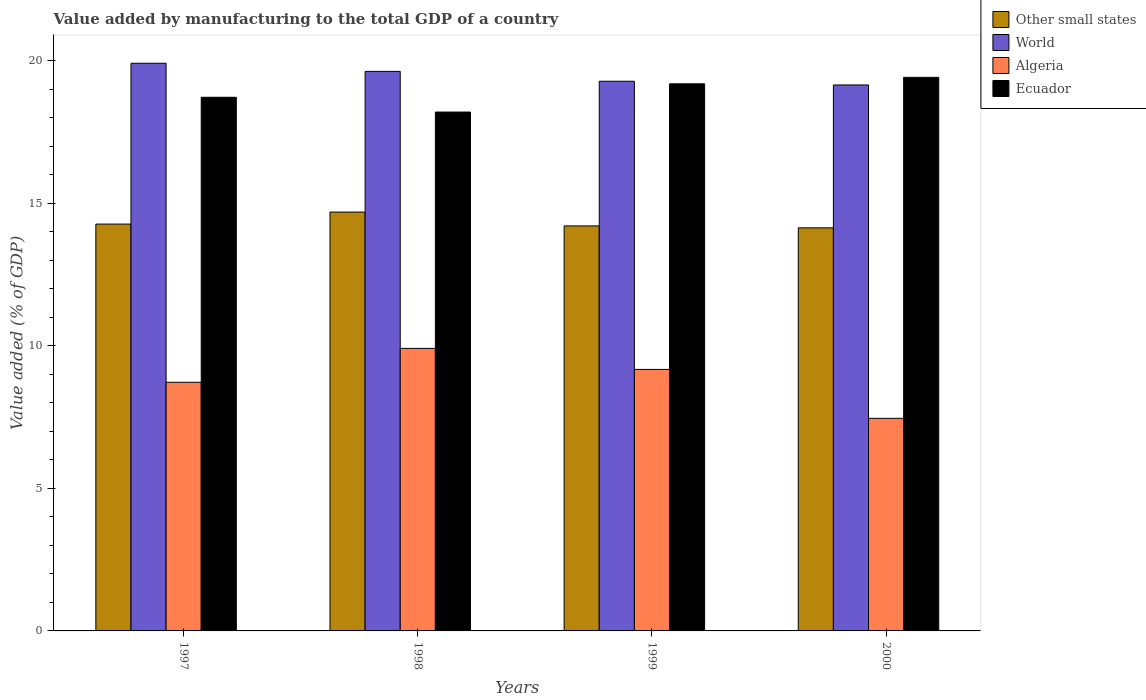How many different coloured bars are there?
Your response must be concise. 4. Are the number of bars per tick equal to the number of legend labels?
Give a very brief answer. Yes. What is the label of the 2nd group of bars from the left?
Your response must be concise. 1998. In how many cases, is the number of bars for a given year not equal to the number of legend labels?
Make the answer very short. 0. What is the value added by manufacturing to the total GDP in World in 2000?
Offer a very short reply. 19.15. Across all years, what is the maximum value added by manufacturing to the total GDP in Algeria?
Offer a terse response. 9.91. Across all years, what is the minimum value added by manufacturing to the total GDP in Other small states?
Give a very brief answer. 14.14. In which year was the value added by manufacturing to the total GDP in Algeria maximum?
Keep it short and to the point. 1998. In which year was the value added by manufacturing to the total GDP in World minimum?
Keep it short and to the point. 2000. What is the total value added by manufacturing to the total GDP in Other small states in the graph?
Offer a terse response. 57.3. What is the difference between the value added by manufacturing to the total GDP in Ecuador in 1999 and that in 2000?
Provide a succinct answer. -0.23. What is the difference between the value added by manufacturing to the total GDP in Algeria in 1997 and the value added by manufacturing to the total GDP in Other small states in 1998?
Your response must be concise. -5.97. What is the average value added by manufacturing to the total GDP in World per year?
Give a very brief answer. 19.49. In the year 1999, what is the difference between the value added by manufacturing to the total GDP in Algeria and value added by manufacturing to the total GDP in Other small states?
Your answer should be compact. -5.03. In how many years, is the value added by manufacturing to the total GDP in Other small states greater than 7 %?
Provide a succinct answer. 4. What is the ratio of the value added by manufacturing to the total GDP in World in 1999 to that in 2000?
Your response must be concise. 1.01. Is the value added by manufacturing to the total GDP in Ecuador in 1999 less than that in 2000?
Provide a succinct answer. Yes. What is the difference between the highest and the second highest value added by manufacturing to the total GDP in Other small states?
Your response must be concise. 0.42. What is the difference between the highest and the lowest value added by manufacturing to the total GDP in Algeria?
Ensure brevity in your answer.  2.45. In how many years, is the value added by manufacturing to the total GDP in Algeria greater than the average value added by manufacturing to the total GDP in Algeria taken over all years?
Your answer should be very brief. 2. Is the sum of the value added by manufacturing to the total GDP in Ecuador in 1998 and 1999 greater than the maximum value added by manufacturing to the total GDP in Other small states across all years?
Give a very brief answer. Yes. Is it the case that in every year, the sum of the value added by manufacturing to the total GDP in Ecuador and value added by manufacturing to the total GDP in World is greater than the sum of value added by manufacturing to the total GDP in Other small states and value added by manufacturing to the total GDP in Algeria?
Provide a short and direct response. Yes. What does the 4th bar from the left in 2000 represents?
Your response must be concise. Ecuador. What does the 1st bar from the right in 2000 represents?
Provide a short and direct response. Ecuador. Is it the case that in every year, the sum of the value added by manufacturing to the total GDP in Other small states and value added by manufacturing to the total GDP in Ecuador is greater than the value added by manufacturing to the total GDP in Algeria?
Offer a very short reply. Yes. How many years are there in the graph?
Ensure brevity in your answer.  4. Are the values on the major ticks of Y-axis written in scientific E-notation?
Offer a terse response. No. Does the graph contain any zero values?
Your answer should be compact. No. Where does the legend appear in the graph?
Provide a short and direct response. Top right. How many legend labels are there?
Provide a short and direct response. 4. How are the legend labels stacked?
Make the answer very short. Vertical. What is the title of the graph?
Offer a terse response. Value added by manufacturing to the total GDP of a country. Does "Congo (Republic)" appear as one of the legend labels in the graph?
Give a very brief answer. No. What is the label or title of the Y-axis?
Offer a very short reply. Value added (% of GDP). What is the Value added (% of GDP) of Other small states in 1997?
Provide a short and direct response. 14.27. What is the Value added (% of GDP) in World in 1997?
Give a very brief answer. 19.91. What is the Value added (% of GDP) in Algeria in 1997?
Make the answer very short. 8.72. What is the Value added (% of GDP) of Ecuador in 1997?
Keep it short and to the point. 18.72. What is the Value added (% of GDP) in Other small states in 1998?
Ensure brevity in your answer.  14.69. What is the Value added (% of GDP) in World in 1998?
Offer a terse response. 19.63. What is the Value added (% of GDP) in Algeria in 1998?
Make the answer very short. 9.91. What is the Value added (% of GDP) of Ecuador in 1998?
Provide a succinct answer. 18.2. What is the Value added (% of GDP) in Other small states in 1999?
Provide a succinct answer. 14.21. What is the Value added (% of GDP) in World in 1999?
Provide a short and direct response. 19.28. What is the Value added (% of GDP) in Algeria in 1999?
Your response must be concise. 9.17. What is the Value added (% of GDP) in Ecuador in 1999?
Give a very brief answer. 19.19. What is the Value added (% of GDP) of Other small states in 2000?
Provide a succinct answer. 14.14. What is the Value added (% of GDP) in World in 2000?
Ensure brevity in your answer.  19.15. What is the Value added (% of GDP) of Algeria in 2000?
Provide a succinct answer. 7.46. What is the Value added (% of GDP) of Ecuador in 2000?
Offer a terse response. 19.42. Across all years, what is the maximum Value added (% of GDP) in Other small states?
Offer a terse response. 14.69. Across all years, what is the maximum Value added (% of GDP) in World?
Provide a short and direct response. 19.91. Across all years, what is the maximum Value added (% of GDP) in Algeria?
Your response must be concise. 9.91. Across all years, what is the maximum Value added (% of GDP) of Ecuador?
Offer a very short reply. 19.42. Across all years, what is the minimum Value added (% of GDP) in Other small states?
Ensure brevity in your answer.  14.14. Across all years, what is the minimum Value added (% of GDP) in World?
Keep it short and to the point. 19.15. Across all years, what is the minimum Value added (% of GDP) in Algeria?
Keep it short and to the point. 7.46. Across all years, what is the minimum Value added (% of GDP) of Ecuador?
Your response must be concise. 18.2. What is the total Value added (% of GDP) of Other small states in the graph?
Your response must be concise. 57.3. What is the total Value added (% of GDP) of World in the graph?
Your answer should be compact. 77.97. What is the total Value added (% of GDP) in Algeria in the graph?
Give a very brief answer. 35.26. What is the total Value added (% of GDP) of Ecuador in the graph?
Offer a very short reply. 75.52. What is the difference between the Value added (% of GDP) in Other small states in 1997 and that in 1998?
Your answer should be compact. -0.42. What is the difference between the Value added (% of GDP) in World in 1997 and that in 1998?
Give a very brief answer. 0.28. What is the difference between the Value added (% of GDP) in Algeria in 1997 and that in 1998?
Your answer should be compact. -1.19. What is the difference between the Value added (% of GDP) of Ecuador in 1997 and that in 1998?
Your response must be concise. 0.52. What is the difference between the Value added (% of GDP) in Other small states in 1997 and that in 1999?
Offer a terse response. 0.06. What is the difference between the Value added (% of GDP) of World in 1997 and that in 1999?
Provide a succinct answer. 0.63. What is the difference between the Value added (% of GDP) in Algeria in 1997 and that in 1999?
Give a very brief answer. -0.45. What is the difference between the Value added (% of GDP) in Ecuador in 1997 and that in 1999?
Provide a succinct answer. -0.47. What is the difference between the Value added (% of GDP) in Other small states in 1997 and that in 2000?
Provide a succinct answer. 0.13. What is the difference between the Value added (% of GDP) of World in 1997 and that in 2000?
Make the answer very short. 0.76. What is the difference between the Value added (% of GDP) of Algeria in 1997 and that in 2000?
Give a very brief answer. 1.26. What is the difference between the Value added (% of GDP) in Ecuador in 1997 and that in 2000?
Keep it short and to the point. -0.7. What is the difference between the Value added (% of GDP) in Other small states in 1998 and that in 1999?
Keep it short and to the point. 0.49. What is the difference between the Value added (% of GDP) of World in 1998 and that in 1999?
Provide a short and direct response. 0.35. What is the difference between the Value added (% of GDP) of Algeria in 1998 and that in 1999?
Provide a succinct answer. 0.74. What is the difference between the Value added (% of GDP) in Ecuador in 1998 and that in 1999?
Keep it short and to the point. -0.99. What is the difference between the Value added (% of GDP) in Other small states in 1998 and that in 2000?
Offer a terse response. 0.55. What is the difference between the Value added (% of GDP) in World in 1998 and that in 2000?
Provide a succinct answer. 0.48. What is the difference between the Value added (% of GDP) of Algeria in 1998 and that in 2000?
Ensure brevity in your answer.  2.45. What is the difference between the Value added (% of GDP) of Ecuador in 1998 and that in 2000?
Offer a terse response. -1.22. What is the difference between the Value added (% of GDP) in Other small states in 1999 and that in 2000?
Provide a short and direct response. 0.07. What is the difference between the Value added (% of GDP) in World in 1999 and that in 2000?
Your response must be concise. 0.13. What is the difference between the Value added (% of GDP) in Algeria in 1999 and that in 2000?
Make the answer very short. 1.72. What is the difference between the Value added (% of GDP) in Ecuador in 1999 and that in 2000?
Ensure brevity in your answer.  -0.23. What is the difference between the Value added (% of GDP) in Other small states in 1997 and the Value added (% of GDP) in World in 1998?
Your answer should be very brief. -5.36. What is the difference between the Value added (% of GDP) in Other small states in 1997 and the Value added (% of GDP) in Algeria in 1998?
Provide a short and direct response. 4.36. What is the difference between the Value added (% of GDP) of Other small states in 1997 and the Value added (% of GDP) of Ecuador in 1998?
Make the answer very short. -3.93. What is the difference between the Value added (% of GDP) of World in 1997 and the Value added (% of GDP) of Algeria in 1998?
Offer a terse response. 10. What is the difference between the Value added (% of GDP) of World in 1997 and the Value added (% of GDP) of Ecuador in 1998?
Offer a terse response. 1.71. What is the difference between the Value added (% of GDP) in Algeria in 1997 and the Value added (% of GDP) in Ecuador in 1998?
Make the answer very short. -9.48. What is the difference between the Value added (% of GDP) of Other small states in 1997 and the Value added (% of GDP) of World in 1999?
Your answer should be compact. -5.01. What is the difference between the Value added (% of GDP) of Other small states in 1997 and the Value added (% of GDP) of Algeria in 1999?
Offer a terse response. 5.1. What is the difference between the Value added (% of GDP) of Other small states in 1997 and the Value added (% of GDP) of Ecuador in 1999?
Your answer should be very brief. -4.92. What is the difference between the Value added (% of GDP) of World in 1997 and the Value added (% of GDP) of Algeria in 1999?
Your answer should be compact. 10.74. What is the difference between the Value added (% of GDP) in World in 1997 and the Value added (% of GDP) in Ecuador in 1999?
Make the answer very short. 0.72. What is the difference between the Value added (% of GDP) of Algeria in 1997 and the Value added (% of GDP) of Ecuador in 1999?
Offer a very short reply. -10.47. What is the difference between the Value added (% of GDP) of Other small states in 1997 and the Value added (% of GDP) of World in 2000?
Your response must be concise. -4.88. What is the difference between the Value added (% of GDP) of Other small states in 1997 and the Value added (% of GDP) of Algeria in 2000?
Your answer should be compact. 6.81. What is the difference between the Value added (% of GDP) in Other small states in 1997 and the Value added (% of GDP) in Ecuador in 2000?
Provide a short and direct response. -5.15. What is the difference between the Value added (% of GDP) in World in 1997 and the Value added (% of GDP) in Algeria in 2000?
Your response must be concise. 12.45. What is the difference between the Value added (% of GDP) of World in 1997 and the Value added (% of GDP) of Ecuador in 2000?
Provide a short and direct response. 0.49. What is the difference between the Value added (% of GDP) of Algeria in 1997 and the Value added (% of GDP) of Ecuador in 2000?
Keep it short and to the point. -10.7. What is the difference between the Value added (% of GDP) of Other small states in 1998 and the Value added (% of GDP) of World in 1999?
Ensure brevity in your answer.  -4.59. What is the difference between the Value added (% of GDP) in Other small states in 1998 and the Value added (% of GDP) in Algeria in 1999?
Your answer should be compact. 5.52. What is the difference between the Value added (% of GDP) of Other small states in 1998 and the Value added (% of GDP) of Ecuador in 1999?
Give a very brief answer. -4.5. What is the difference between the Value added (% of GDP) in World in 1998 and the Value added (% of GDP) in Algeria in 1999?
Your answer should be very brief. 10.45. What is the difference between the Value added (% of GDP) in World in 1998 and the Value added (% of GDP) in Ecuador in 1999?
Provide a succinct answer. 0.44. What is the difference between the Value added (% of GDP) in Algeria in 1998 and the Value added (% of GDP) in Ecuador in 1999?
Your answer should be compact. -9.28. What is the difference between the Value added (% of GDP) in Other small states in 1998 and the Value added (% of GDP) in World in 2000?
Keep it short and to the point. -4.46. What is the difference between the Value added (% of GDP) in Other small states in 1998 and the Value added (% of GDP) in Algeria in 2000?
Keep it short and to the point. 7.23. What is the difference between the Value added (% of GDP) in Other small states in 1998 and the Value added (% of GDP) in Ecuador in 2000?
Provide a succinct answer. -4.73. What is the difference between the Value added (% of GDP) of World in 1998 and the Value added (% of GDP) of Algeria in 2000?
Offer a terse response. 12.17. What is the difference between the Value added (% of GDP) in World in 1998 and the Value added (% of GDP) in Ecuador in 2000?
Provide a succinct answer. 0.21. What is the difference between the Value added (% of GDP) in Algeria in 1998 and the Value added (% of GDP) in Ecuador in 2000?
Your answer should be very brief. -9.51. What is the difference between the Value added (% of GDP) of Other small states in 1999 and the Value added (% of GDP) of World in 2000?
Make the answer very short. -4.94. What is the difference between the Value added (% of GDP) in Other small states in 1999 and the Value added (% of GDP) in Algeria in 2000?
Provide a short and direct response. 6.75. What is the difference between the Value added (% of GDP) in Other small states in 1999 and the Value added (% of GDP) in Ecuador in 2000?
Give a very brief answer. -5.21. What is the difference between the Value added (% of GDP) in World in 1999 and the Value added (% of GDP) in Algeria in 2000?
Offer a terse response. 11.82. What is the difference between the Value added (% of GDP) in World in 1999 and the Value added (% of GDP) in Ecuador in 2000?
Your answer should be compact. -0.14. What is the difference between the Value added (% of GDP) of Algeria in 1999 and the Value added (% of GDP) of Ecuador in 2000?
Your answer should be very brief. -10.24. What is the average Value added (% of GDP) in Other small states per year?
Offer a very short reply. 14.33. What is the average Value added (% of GDP) in World per year?
Your response must be concise. 19.49. What is the average Value added (% of GDP) in Algeria per year?
Ensure brevity in your answer.  8.81. What is the average Value added (% of GDP) of Ecuador per year?
Ensure brevity in your answer.  18.88. In the year 1997, what is the difference between the Value added (% of GDP) of Other small states and Value added (% of GDP) of World?
Offer a very short reply. -5.64. In the year 1997, what is the difference between the Value added (% of GDP) in Other small states and Value added (% of GDP) in Algeria?
Ensure brevity in your answer.  5.55. In the year 1997, what is the difference between the Value added (% of GDP) of Other small states and Value added (% of GDP) of Ecuador?
Give a very brief answer. -4.45. In the year 1997, what is the difference between the Value added (% of GDP) in World and Value added (% of GDP) in Algeria?
Your answer should be very brief. 11.19. In the year 1997, what is the difference between the Value added (% of GDP) of World and Value added (% of GDP) of Ecuador?
Keep it short and to the point. 1.19. In the year 1997, what is the difference between the Value added (% of GDP) in Algeria and Value added (% of GDP) in Ecuador?
Your response must be concise. -10. In the year 1998, what is the difference between the Value added (% of GDP) in Other small states and Value added (% of GDP) in World?
Make the answer very short. -4.94. In the year 1998, what is the difference between the Value added (% of GDP) in Other small states and Value added (% of GDP) in Algeria?
Keep it short and to the point. 4.78. In the year 1998, what is the difference between the Value added (% of GDP) of Other small states and Value added (% of GDP) of Ecuador?
Ensure brevity in your answer.  -3.51. In the year 1998, what is the difference between the Value added (% of GDP) of World and Value added (% of GDP) of Algeria?
Offer a terse response. 9.72. In the year 1998, what is the difference between the Value added (% of GDP) of World and Value added (% of GDP) of Ecuador?
Keep it short and to the point. 1.43. In the year 1998, what is the difference between the Value added (% of GDP) of Algeria and Value added (% of GDP) of Ecuador?
Give a very brief answer. -8.29. In the year 1999, what is the difference between the Value added (% of GDP) in Other small states and Value added (% of GDP) in World?
Make the answer very short. -5.07. In the year 1999, what is the difference between the Value added (% of GDP) of Other small states and Value added (% of GDP) of Algeria?
Your answer should be very brief. 5.03. In the year 1999, what is the difference between the Value added (% of GDP) in Other small states and Value added (% of GDP) in Ecuador?
Provide a succinct answer. -4.98. In the year 1999, what is the difference between the Value added (% of GDP) in World and Value added (% of GDP) in Algeria?
Offer a terse response. 10.11. In the year 1999, what is the difference between the Value added (% of GDP) of World and Value added (% of GDP) of Ecuador?
Keep it short and to the point. 0.09. In the year 1999, what is the difference between the Value added (% of GDP) of Algeria and Value added (% of GDP) of Ecuador?
Ensure brevity in your answer.  -10.02. In the year 2000, what is the difference between the Value added (% of GDP) in Other small states and Value added (% of GDP) in World?
Offer a terse response. -5.01. In the year 2000, what is the difference between the Value added (% of GDP) in Other small states and Value added (% of GDP) in Algeria?
Make the answer very short. 6.68. In the year 2000, what is the difference between the Value added (% of GDP) of Other small states and Value added (% of GDP) of Ecuador?
Ensure brevity in your answer.  -5.28. In the year 2000, what is the difference between the Value added (% of GDP) of World and Value added (% of GDP) of Algeria?
Keep it short and to the point. 11.69. In the year 2000, what is the difference between the Value added (% of GDP) in World and Value added (% of GDP) in Ecuador?
Your answer should be very brief. -0.27. In the year 2000, what is the difference between the Value added (% of GDP) of Algeria and Value added (% of GDP) of Ecuador?
Provide a short and direct response. -11.96. What is the ratio of the Value added (% of GDP) of Other small states in 1997 to that in 1998?
Provide a short and direct response. 0.97. What is the ratio of the Value added (% of GDP) of World in 1997 to that in 1998?
Your answer should be compact. 1.01. What is the ratio of the Value added (% of GDP) of Ecuador in 1997 to that in 1998?
Provide a succinct answer. 1.03. What is the ratio of the Value added (% of GDP) of World in 1997 to that in 1999?
Offer a terse response. 1.03. What is the ratio of the Value added (% of GDP) in Algeria in 1997 to that in 1999?
Ensure brevity in your answer.  0.95. What is the ratio of the Value added (% of GDP) in Ecuador in 1997 to that in 1999?
Offer a terse response. 0.98. What is the ratio of the Value added (% of GDP) of Other small states in 1997 to that in 2000?
Your answer should be compact. 1.01. What is the ratio of the Value added (% of GDP) of World in 1997 to that in 2000?
Your answer should be compact. 1.04. What is the ratio of the Value added (% of GDP) in Algeria in 1997 to that in 2000?
Keep it short and to the point. 1.17. What is the ratio of the Value added (% of GDP) in Other small states in 1998 to that in 1999?
Your answer should be compact. 1.03. What is the ratio of the Value added (% of GDP) of World in 1998 to that in 1999?
Keep it short and to the point. 1.02. What is the ratio of the Value added (% of GDP) in Algeria in 1998 to that in 1999?
Your answer should be compact. 1.08. What is the ratio of the Value added (% of GDP) of Ecuador in 1998 to that in 1999?
Offer a terse response. 0.95. What is the ratio of the Value added (% of GDP) of Other small states in 1998 to that in 2000?
Give a very brief answer. 1.04. What is the ratio of the Value added (% of GDP) of World in 1998 to that in 2000?
Your answer should be very brief. 1.02. What is the ratio of the Value added (% of GDP) of Algeria in 1998 to that in 2000?
Provide a succinct answer. 1.33. What is the ratio of the Value added (% of GDP) in Ecuador in 1998 to that in 2000?
Keep it short and to the point. 0.94. What is the ratio of the Value added (% of GDP) in Other small states in 1999 to that in 2000?
Ensure brevity in your answer.  1. What is the ratio of the Value added (% of GDP) of World in 1999 to that in 2000?
Offer a terse response. 1.01. What is the ratio of the Value added (% of GDP) of Algeria in 1999 to that in 2000?
Your answer should be compact. 1.23. What is the ratio of the Value added (% of GDP) of Ecuador in 1999 to that in 2000?
Ensure brevity in your answer.  0.99. What is the difference between the highest and the second highest Value added (% of GDP) in Other small states?
Offer a terse response. 0.42. What is the difference between the highest and the second highest Value added (% of GDP) of World?
Your response must be concise. 0.28. What is the difference between the highest and the second highest Value added (% of GDP) in Algeria?
Ensure brevity in your answer.  0.74. What is the difference between the highest and the second highest Value added (% of GDP) of Ecuador?
Give a very brief answer. 0.23. What is the difference between the highest and the lowest Value added (% of GDP) in Other small states?
Ensure brevity in your answer.  0.55. What is the difference between the highest and the lowest Value added (% of GDP) in World?
Offer a terse response. 0.76. What is the difference between the highest and the lowest Value added (% of GDP) of Algeria?
Keep it short and to the point. 2.45. What is the difference between the highest and the lowest Value added (% of GDP) in Ecuador?
Your answer should be very brief. 1.22. 